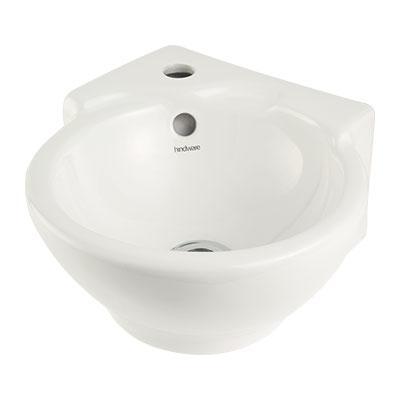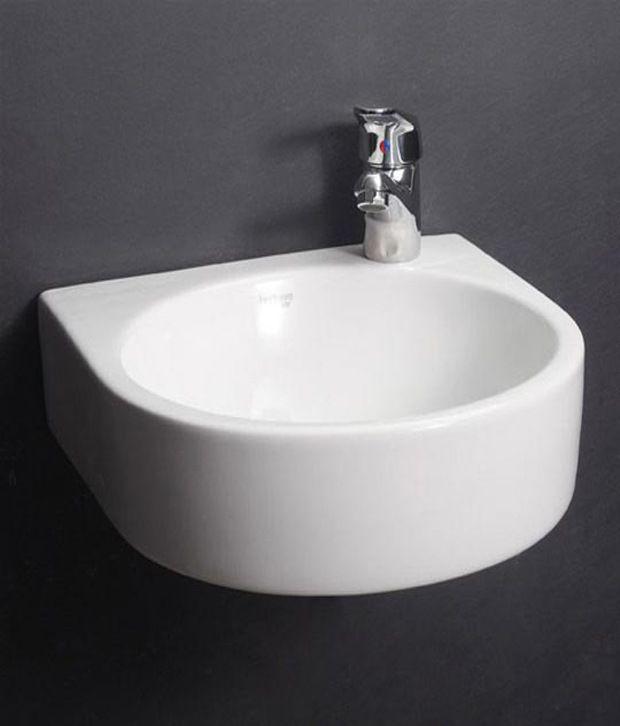The first image is the image on the left, the second image is the image on the right. Examine the images to the left and right. Is the description "At least one sink has no background, just plain white." accurate? Answer yes or no. Yes. 